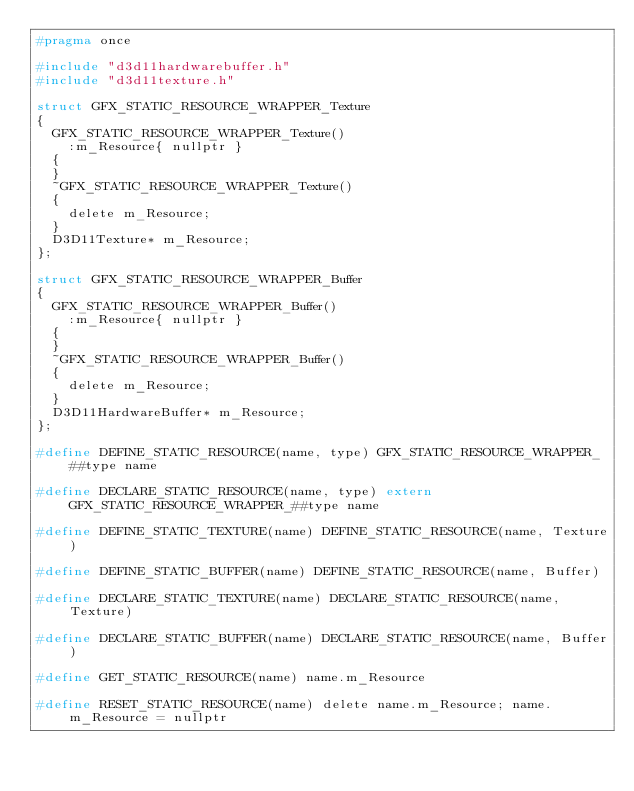Convert code to text. <code><loc_0><loc_0><loc_500><loc_500><_C_>#pragma once

#include "d3d11hardwarebuffer.h"
#include "d3d11texture.h"

struct GFX_STATIC_RESOURCE_WRAPPER_Texture
{
  GFX_STATIC_RESOURCE_WRAPPER_Texture()
    :m_Resource{ nullptr }
  {
  }
  ~GFX_STATIC_RESOURCE_WRAPPER_Texture()
  {
    delete m_Resource;
  }
  D3D11Texture* m_Resource;
};

struct GFX_STATIC_RESOURCE_WRAPPER_Buffer
{
  GFX_STATIC_RESOURCE_WRAPPER_Buffer()
    :m_Resource{ nullptr }
  {
  }
  ~GFX_STATIC_RESOURCE_WRAPPER_Buffer()
  {
    delete m_Resource;
  }
  D3D11HardwareBuffer* m_Resource;
};

#define DEFINE_STATIC_RESOURCE(name, type) GFX_STATIC_RESOURCE_WRAPPER_##type name

#define DECLARE_STATIC_RESOURCE(name, type) extern GFX_STATIC_RESOURCE_WRAPPER_##type name

#define DEFINE_STATIC_TEXTURE(name) DEFINE_STATIC_RESOURCE(name, Texture)

#define DEFINE_STATIC_BUFFER(name) DEFINE_STATIC_RESOURCE(name, Buffer)

#define DECLARE_STATIC_TEXTURE(name) DECLARE_STATIC_RESOURCE(name, Texture)

#define DECLARE_STATIC_BUFFER(name) DECLARE_STATIC_RESOURCE(name, Buffer)

#define GET_STATIC_RESOURCE(name) name.m_Resource

#define RESET_STATIC_RESOURCE(name) delete name.m_Resource; name.m_Resource = nullptr
</code> 